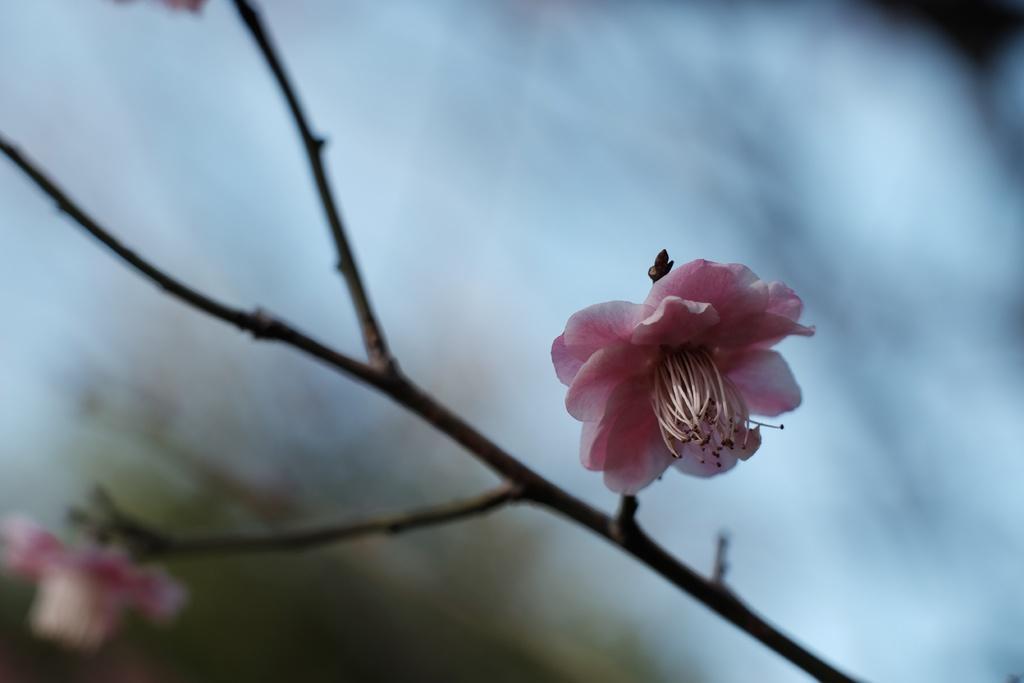Can you describe this image briefly? In this picture we can see a few flowers and stems. Background is blurry. 